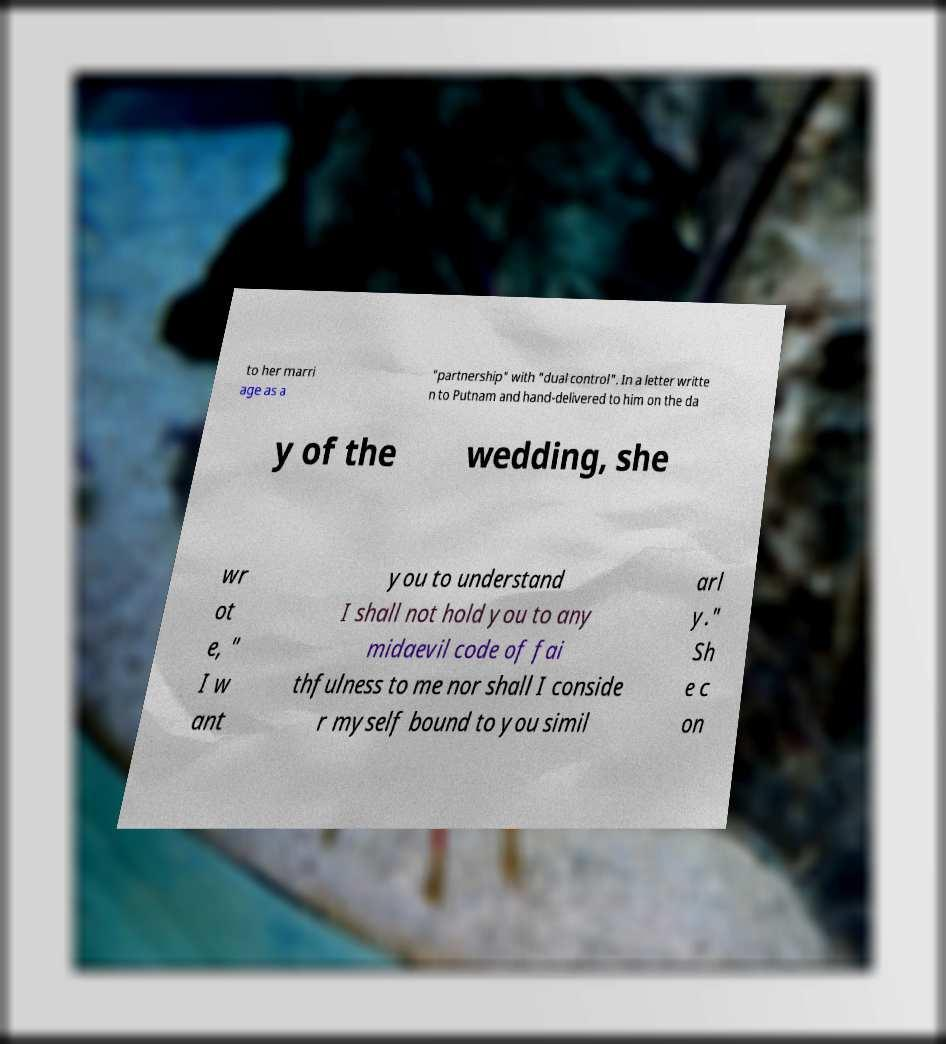Please read and relay the text visible in this image. What does it say? to her marri age as a "partnership" with "dual control". In a letter writte n to Putnam and hand-delivered to him on the da y of the wedding, she wr ot e, " I w ant you to understand I shall not hold you to any midaevil code of fai thfulness to me nor shall I conside r myself bound to you simil arl y." Sh e c on 